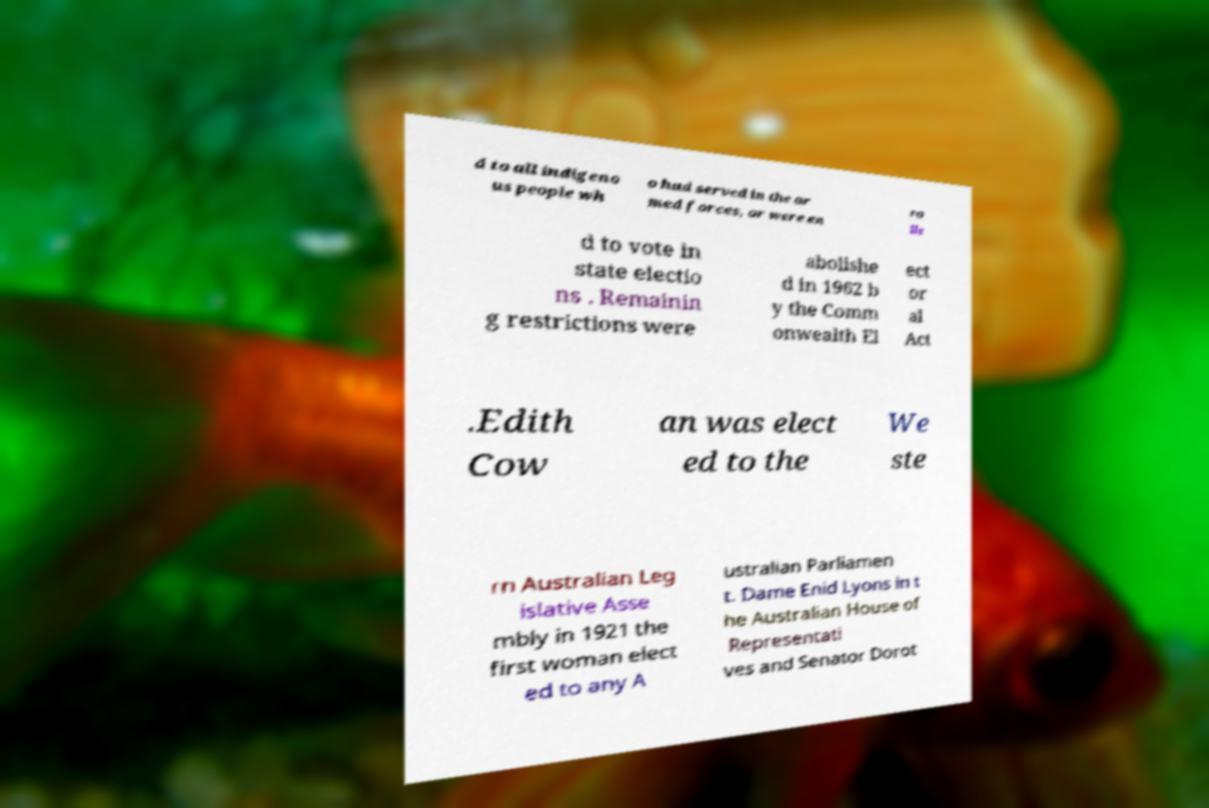Could you extract and type out the text from this image? d to all indigeno us people wh o had served in the ar med forces, or were en ro lle d to vote in state electio ns . Remainin g restrictions were abolishe d in 1962 b y the Comm onwealth El ect or al Act .Edith Cow an was elect ed to the We ste rn Australian Leg islative Asse mbly in 1921 the first woman elect ed to any A ustralian Parliamen t. Dame Enid Lyons in t he Australian House of Representati ves and Senator Dorot 